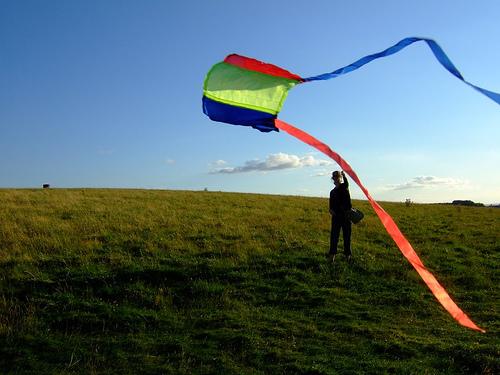What is the weather like?
Keep it brief. Sunny. What color is the kite?
Quick response, please. Green blue red. Are these kite strips a tripping hazard?
Be succinct. No. 